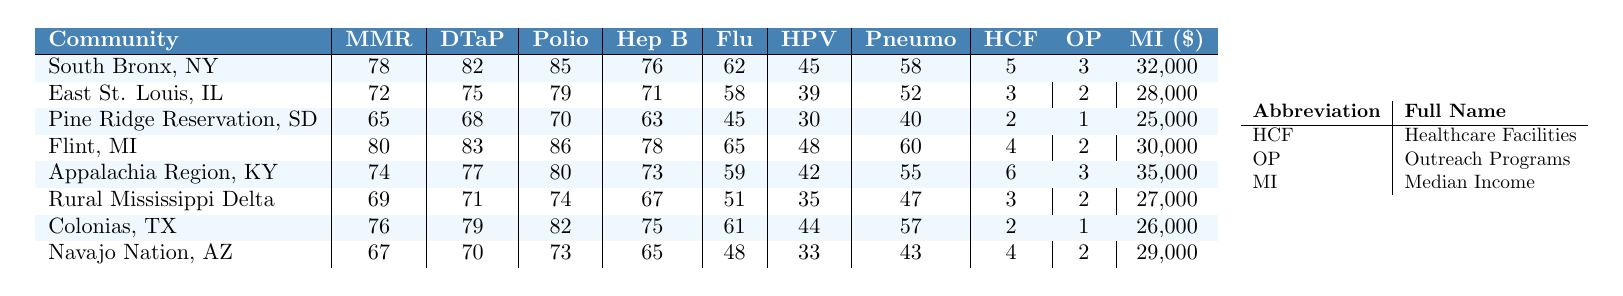What is the vaccination rate for MMR in Flint, MI? The table lists the vaccination rate for MMR in Flint, MI as 80.
Answer: 80 Which community has the highest influenza vaccination rate? By looking at the influenza vaccination rates, Flint, MI has the highest rate at 65.
Answer: Flint, MI What are the healthcare facilities available in Colonias, TX? The table shows that there are 2 healthcare facilities in Colonias, TX.
Answer: 2 What is the median income for the Pine Ridge Reservation, SD? The median income for the Pine Ridge Reservation, SD is listed as 25,000.
Answer: 25,000 Which community has the lowest vaccination rate for Hepatitis B? The Hepatitis B vaccination rate for Pine Ridge Reservation, SD is the lowest at 63.
Answer: Pine Ridge Reservation, SD What is the average vaccination rate for DTaP across all communities? To find the average, we sum the DTaP rates: 82 + 75 + 68 + 83 + 77 + 71 + 79 + 70 = 605, and divide by 8: 605 / 8 = 75.625.
Answer: 75.625 Is the median income higher in South Bronx, NY than in East St. Louis, IL? The median income for South Bronx, NY is 32,000, while East St. Louis, IL has a median income of 28,000. Since 32,000 is greater than 28,000, the statement is true.
Answer: Yes How many outreach programs are available in the Appalachia Region, KY? The table indicates that there are 3 outreach programs available in the Appalachia Region, KY.
Answer: 3 What is the difference in the vaccination rate for Polio between South Bronx, NY and Rural Mississippi Delta? The Polio vaccination rate for South Bronx, NY is 85 and for Rural Mississippi Delta, it is 74. The difference is 85 - 74 = 11.
Answer: 11 Which community has the combined lowest vaccination rates across all vaccines listed? By summing the vaccination rates for each community and comparing: Pine Ridge Reservation, SD has the lowest total of 40 + 30 + 45 + 63 + 70 + 68 + 65 = 275.
Answer: Pine Ridge Reservation, SD 